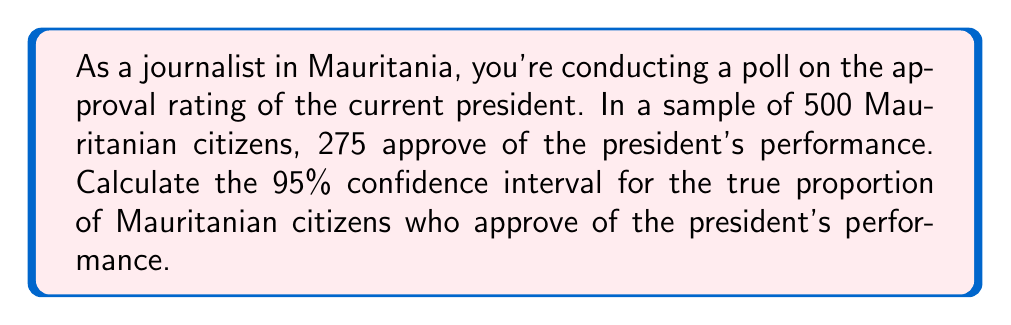Could you help me with this problem? Let's approach this step-by-step:

1) First, we need to calculate the sample proportion:
   $\hat{p} = \frac{275}{500} = 0.55$ or 55%

2) For a 95% confidence interval, we use a z-score of 1.96.

3) The formula for the confidence interval is:

   $$\hat{p} \pm z \sqrt{\frac{\hat{p}(1-\hat{p})}{n}}$$

   Where:
   $\hat{p}$ is the sample proportion
   $z$ is the z-score (1.96 for 95% confidence)
   $n$ is the sample size

4) Let's calculate the standard error:

   $$\sqrt{\frac{\hat{p}(1-\hat{p})}{n}} = \sqrt{\frac{0.55(1-0.55)}{500}} = \sqrt{\frac{0.2475}{500}} = 0.0222$$

5) Now, let's calculate the margin of error:

   $$1.96 \times 0.0222 = 0.0435$$

6) Finally, we can calculate the confidence interval:

   Lower bound: $0.55 - 0.0435 = 0.5065$ or 50.65%
   Upper bound: $0.55 + 0.0435 = 0.5935$ or 59.35%

Therefore, we can say with 95% confidence that the true proportion of Mauritanian citizens who approve of the president's performance is between 50.65% and 59.35%.
Answer: (50.65%, 59.35%) 